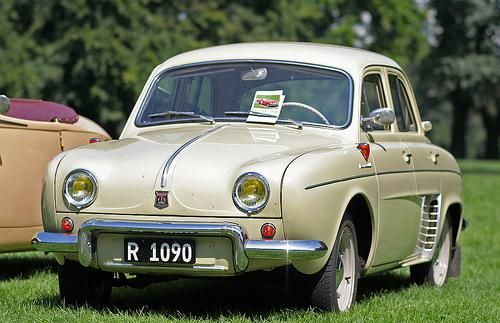Would there be a car in the image after the car disappeared from this picture? If the car disappeared from the image, you would no longer see the car itself; instead, you would see only the background which includes the grass and trees. 